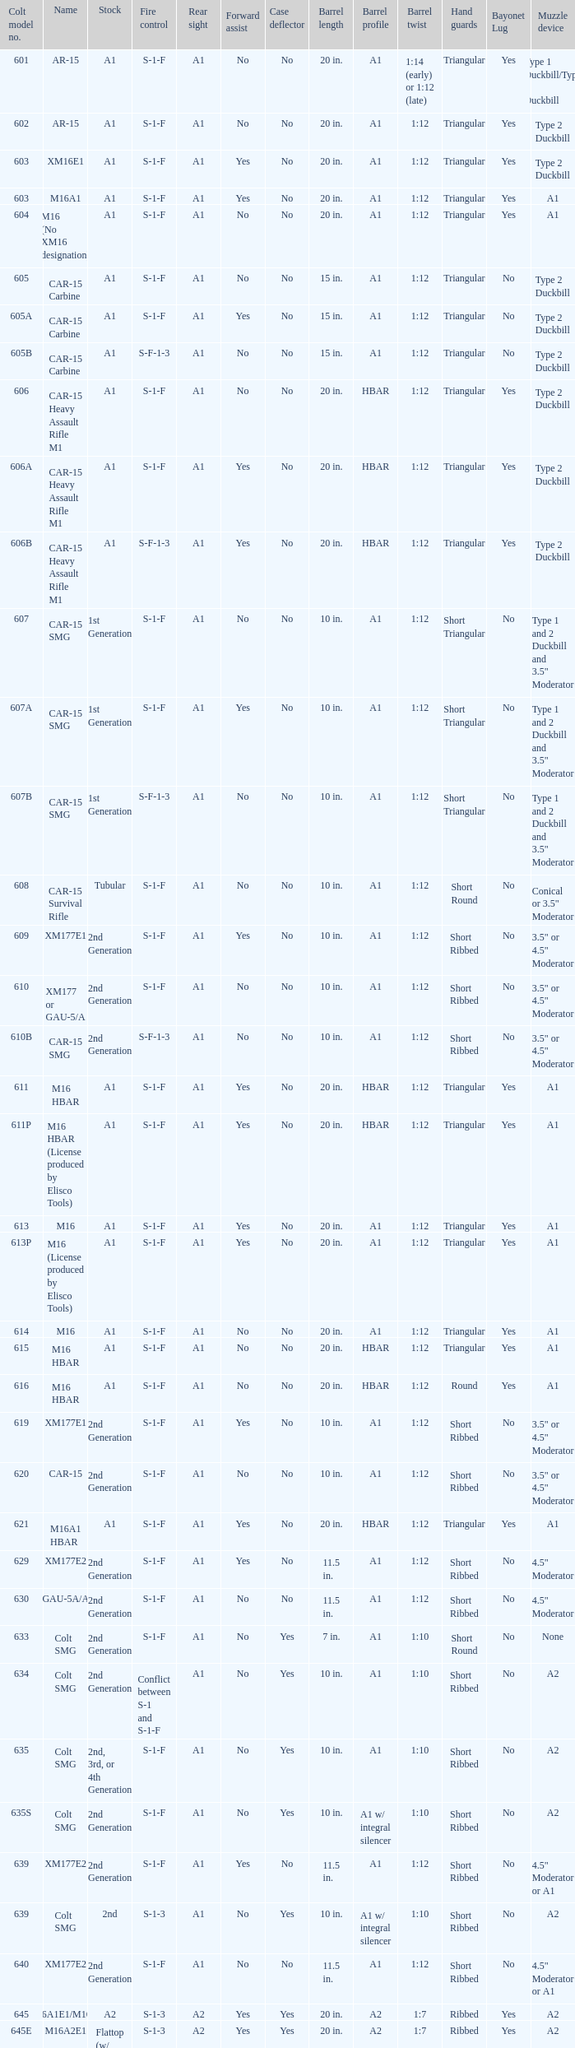What's the type of muzzle devices on the models with round hand guards? A1. 